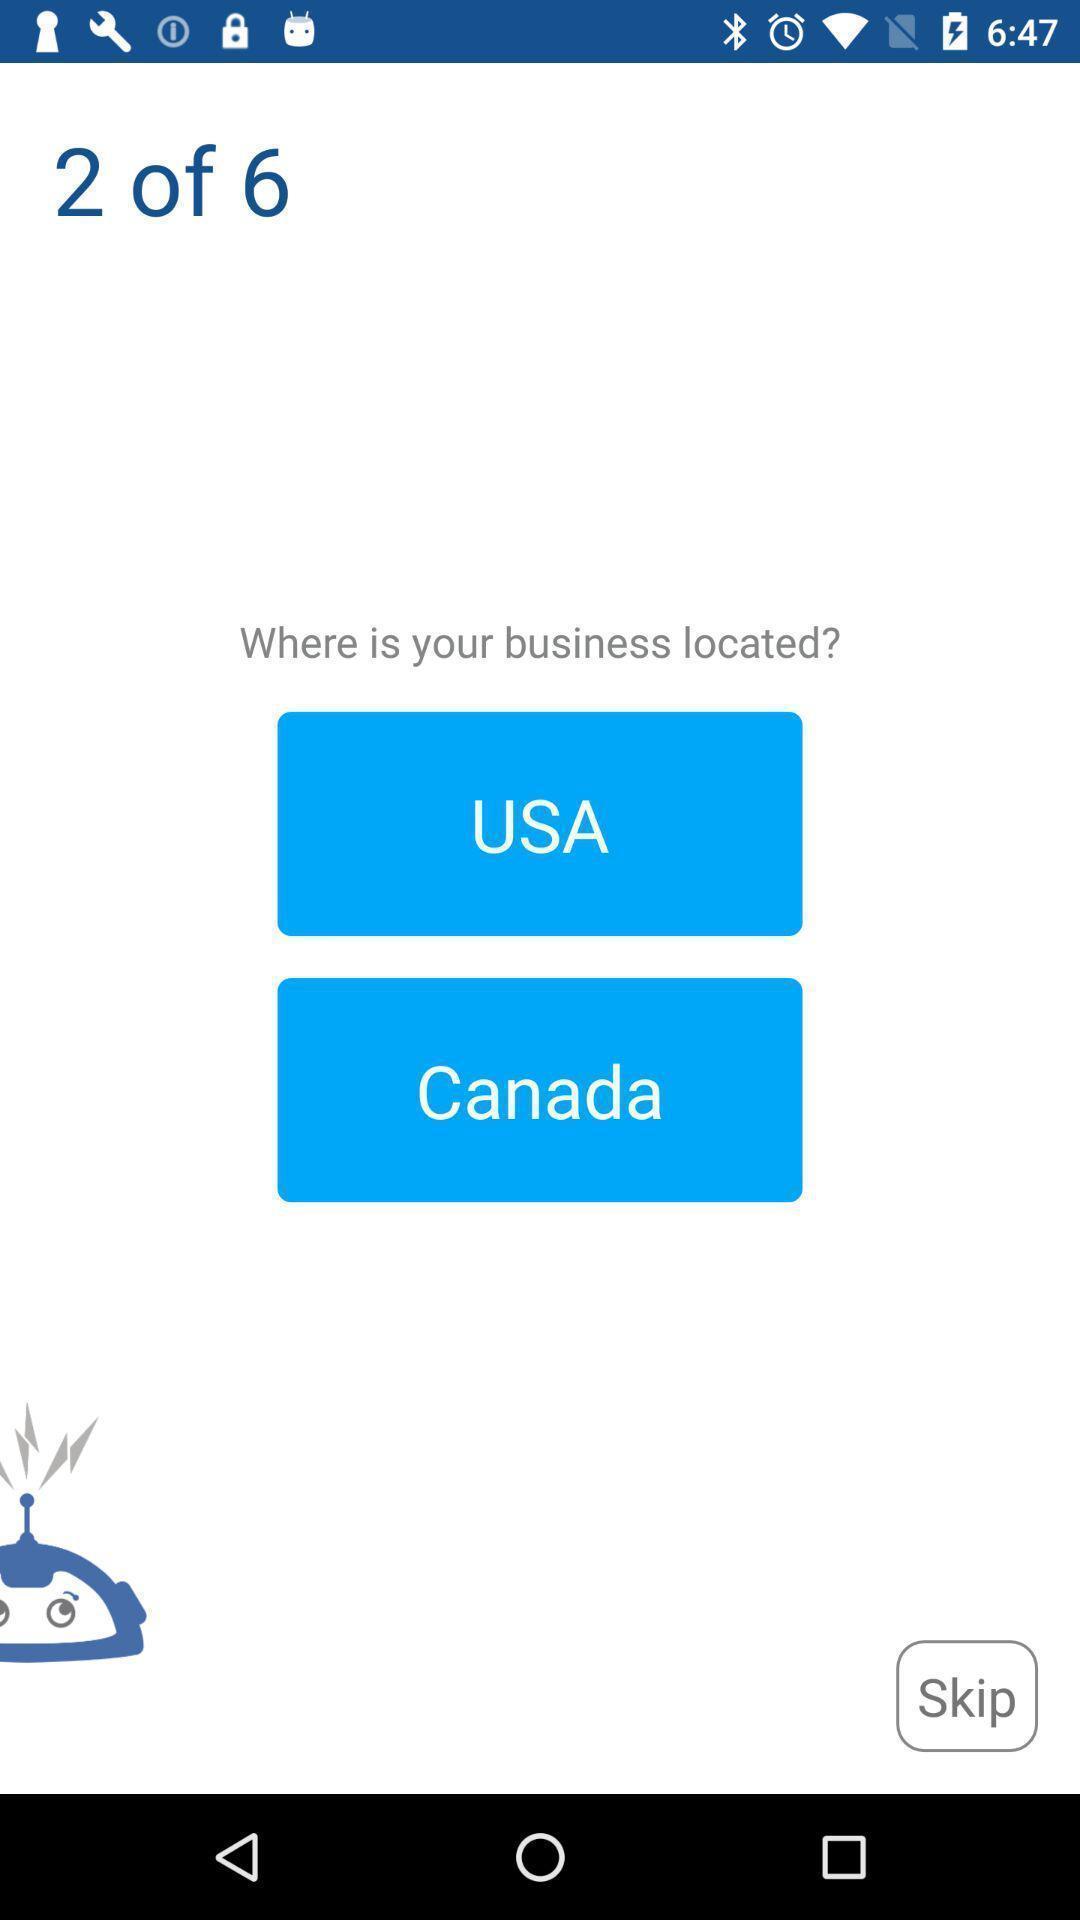Summarize the main components in this picture. Screen asking the business location. 